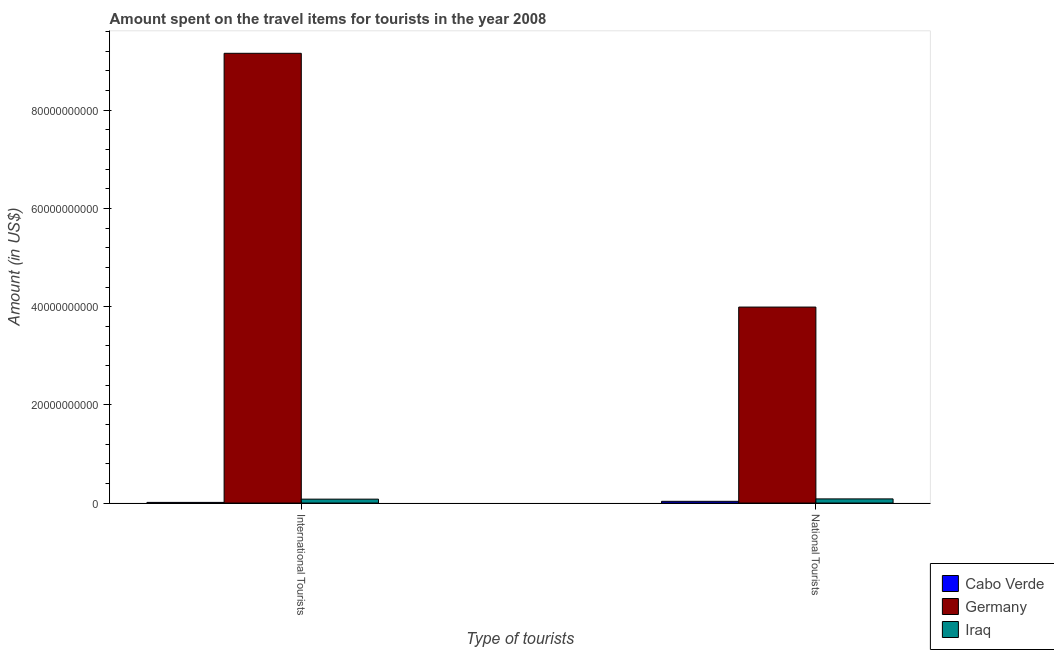Are the number of bars on each tick of the X-axis equal?
Give a very brief answer. Yes. How many bars are there on the 1st tick from the left?
Keep it short and to the point. 3. How many bars are there on the 2nd tick from the right?
Make the answer very short. 3. What is the label of the 2nd group of bars from the left?
Your response must be concise. National Tourists. What is the amount spent on travel items of national tourists in Iraq?
Your answer should be very brief. 8.45e+08. Across all countries, what is the maximum amount spent on travel items of national tourists?
Provide a short and direct response. 3.99e+1. Across all countries, what is the minimum amount spent on travel items of national tourists?
Provide a short and direct response. 3.52e+08. In which country was the amount spent on travel items of national tourists maximum?
Provide a short and direct response. Germany. In which country was the amount spent on travel items of international tourists minimum?
Your answer should be very brief. Cabo Verde. What is the total amount spent on travel items of international tourists in the graph?
Make the answer very short. 9.25e+1. What is the difference between the amount spent on travel items of international tourists in Iraq and that in Germany?
Offer a terse response. -9.08e+1. What is the difference between the amount spent on travel items of national tourists in Iraq and the amount spent on travel items of international tourists in Germany?
Give a very brief answer. -9.08e+1. What is the average amount spent on travel items of national tourists per country?
Provide a succinct answer. 1.37e+1. What is the difference between the amount spent on travel items of international tourists and amount spent on travel items of national tourists in Cabo Verde?
Provide a short and direct response. -2.19e+08. In how many countries, is the amount spent on travel items of national tourists greater than 80000000000 US$?
Your response must be concise. 0. What is the ratio of the amount spent on travel items of national tourists in Iraq to that in Germany?
Your answer should be very brief. 0.02. Is the amount spent on travel items of national tourists in Iraq less than that in Germany?
Provide a succinct answer. Yes. What does the 1st bar from the left in International Tourists represents?
Ensure brevity in your answer.  Cabo Verde. What does the 2nd bar from the right in National Tourists represents?
Your response must be concise. Germany. How many bars are there?
Give a very brief answer. 6. What is the difference between two consecutive major ticks on the Y-axis?
Offer a very short reply. 2.00e+1. Are the values on the major ticks of Y-axis written in scientific E-notation?
Ensure brevity in your answer.  No. Where does the legend appear in the graph?
Your answer should be very brief. Bottom right. How are the legend labels stacked?
Provide a succinct answer. Vertical. What is the title of the graph?
Offer a terse response. Amount spent on the travel items for tourists in the year 2008. What is the label or title of the X-axis?
Offer a very short reply. Type of tourists. What is the Amount (in US$) in Cabo Verde in International Tourists?
Your response must be concise. 1.33e+08. What is the Amount (in US$) of Germany in International Tourists?
Give a very brief answer. 9.16e+1. What is the Amount (in US$) of Iraq in International Tourists?
Keep it short and to the point. 7.94e+08. What is the Amount (in US$) in Cabo Verde in National Tourists?
Make the answer very short. 3.52e+08. What is the Amount (in US$) in Germany in National Tourists?
Your answer should be very brief. 3.99e+1. What is the Amount (in US$) of Iraq in National Tourists?
Offer a very short reply. 8.45e+08. Across all Type of tourists, what is the maximum Amount (in US$) of Cabo Verde?
Give a very brief answer. 3.52e+08. Across all Type of tourists, what is the maximum Amount (in US$) of Germany?
Ensure brevity in your answer.  9.16e+1. Across all Type of tourists, what is the maximum Amount (in US$) of Iraq?
Provide a short and direct response. 8.45e+08. Across all Type of tourists, what is the minimum Amount (in US$) of Cabo Verde?
Give a very brief answer. 1.33e+08. Across all Type of tourists, what is the minimum Amount (in US$) of Germany?
Ensure brevity in your answer.  3.99e+1. Across all Type of tourists, what is the minimum Amount (in US$) in Iraq?
Keep it short and to the point. 7.94e+08. What is the total Amount (in US$) of Cabo Verde in the graph?
Your response must be concise. 4.85e+08. What is the total Amount (in US$) in Germany in the graph?
Provide a succinct answer. 1.32e+11. What is the total Amount (in US$) of Iraq in the graph?
Provide a succinct answer. 1.64e+09. What is the difference between the Amount (in US$) of Cabo Verde in International Tourists and that in National Tourists?
Keep it short and to the point. -2.19e+08. What is the difference between the Amount (in US$) of Germany in International Tourists and that in National Tourists?
Offer a very short reply. 5.17e+1. What is the difference between the Amount (in US$) in Iraq in International Tourists and that in National Tourists?
Make the answer very short. -5.10e+07. What is the difference between the Amount (in US$) of Cabo Verde in International Tourists and the Amount (in US$) of Germany in National Tourists?
Offer a terse response. -3.98e+1. What is the difference between the Amount (in US$) of Cabo Verde in International Tourists and the Amount (in US$) of Iraq in National Tourists?
Offer a very short reply. -7.12e+08. What is the difference between the Amount (in US$) of Germany in International Tourists and the Amount (in US$) of Iraq in National Tourists?
Make the answer very short. 9.08e+1. What is the average Amount (in US$) of Cabo Verde per Type of tourists?
Offer a very short reply. 2.42e+08. What is the average Amount (in US$) in Germany per Type of tourists?
Ensure brevity in your answer.  6.58e+1. What is the average Amount (in US$) of Iraq per Type of tourists?
Offer a terse response. 8.20e+08. What is the difference between the Amount (in US$) of Cabo Verde and Amount (in US$) of Germany in International Tourists?
Offer a terse response. -9.15e+1. What is the difference between the Amount (in US$) in Cabo Verde and Amount (in US$) in Iraq in International Tourists?
Offer a terse response. -6.61e+08. What is the difference between the Amount (in US$) in Germany and Amount (in US$) in Iraq in International Tourists?
Keep it short and to the point. 9.08e+1. What is the difference between the Amount (in US$) in Cabo Verde and Amount (in US$) in Germany in National Tourists?
Your answer should be very brief. -3.96e+1. What is the difference between the Amount (in US$) in Cabo Verde and Amount (in US$) in Iraq in National Tourists?
Your answer should be compact. -4.93e+08. What is the difference between the Amount (in US$) in Germany and Amount (in US$) in Iraq in National Tourists?
Keep it short and to the point. 3.91e+1. What is the ratio of the Amount (in US$) in Cabo Verde in International Tourists to that in National Tourists?
Your answer should be compact. 0.38. What is the ratio of the Amount (in US$) in Germany in International Tourists to that in National Tourists?
Your response must be concise. 2.29. What is the ratio of the Amount (in US$) in Iraq in International Tourists to that in National Tourists?
Keep it short and to the point. 0.94. What is the difference between the highest and the second highest Amount (in US$) of Cabo Verde?
Offer a very short reply. 2.19e+08. What is the difference between the highest and the second highest Amount (in US$) of Germany?
Your answer should be very brief. 5.17e+1. What is the difference between the highest and the second highest Amount (in US$) in Iraq?
Your answer should be compact. 5.10e+07. What is the difference between the highest and the lowest Amount (in US$) in Cabo Verde?
Keep it short and to the point. 2.19e+08. What is the difference between the highest and the lowest Amount (in US$) of Germany?
Provide a short and direct response. 5.17e+1. What is the difference between the highest and the lowest Amount (in US$) of Iraq?
Your answer should be very brief. 5.10e+07. 